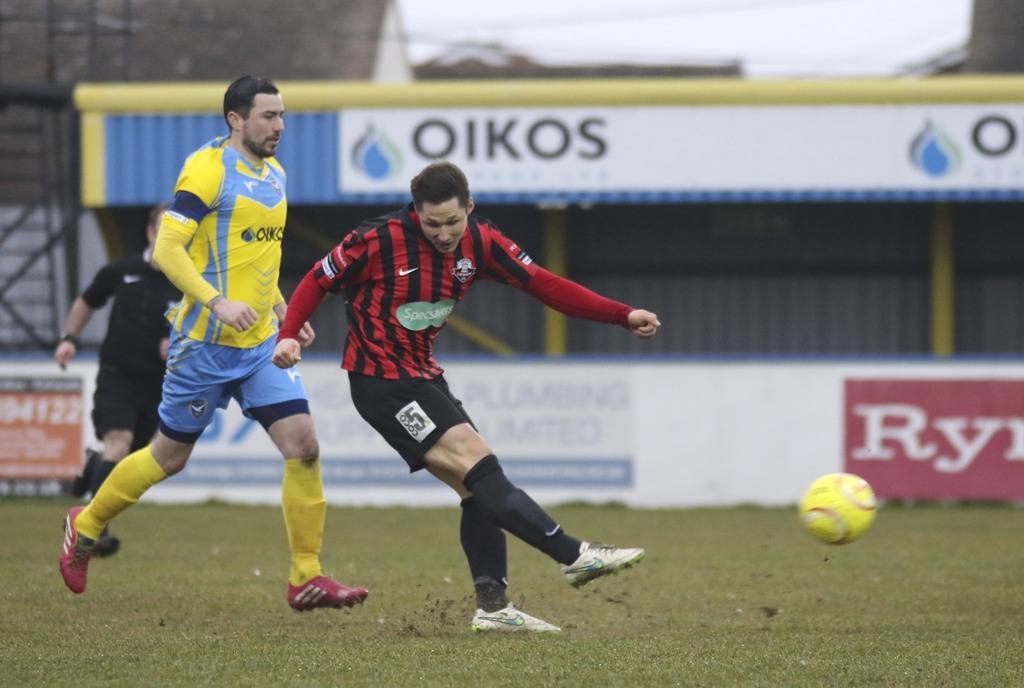How would you summarize this image in a sentence or two? In this image we can see persons standing on the ground. In the background we can see shed and advertisement boards. In the foreground we can see a ball. 